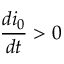Convert formula to latex. <formula><loc_0><loc_0><loc_500><loc_500>\frac { d i _ { 0 } } { d t } > 0</formula> 